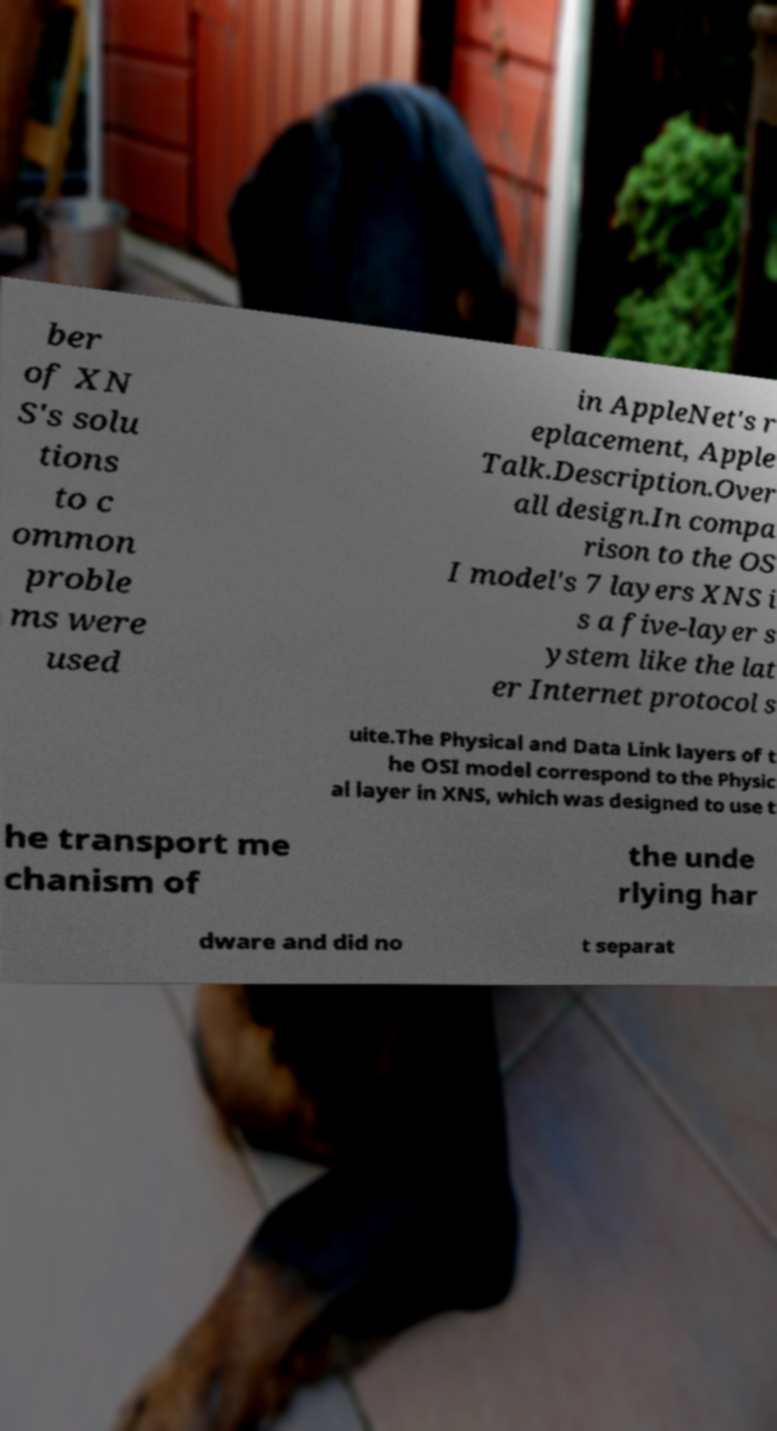Please read and relay the text visible in this image. What does it say? ber of XN S's solu tions to c ommon proble ms were used in AppleNet's r eplacement, Apple Talk.Description.Over all design.In compa rison to the OS I model's 7 layers XNS i s a five-layer s ystem like the lat er Internet protocol s uite.The Physical and Data Link layers of t he OSI model correspond to the Physic al layer in XNS, which was designed to use t he transport me chanism of the unde rlying har dware and did no t separat 